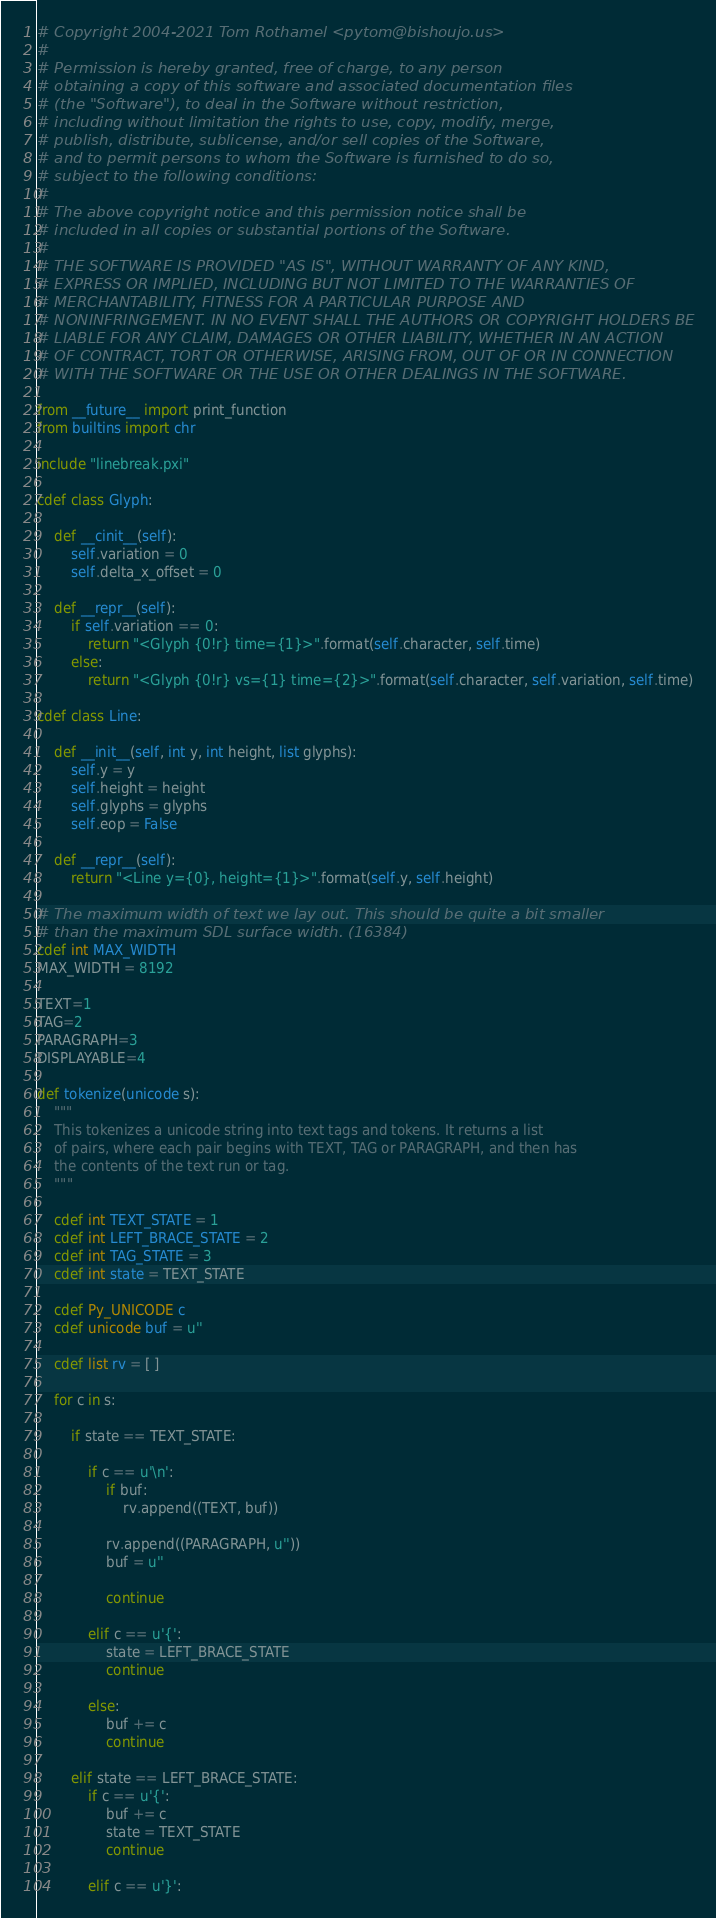Convert code to text. <code><loc_0><loc_0><loc_500><loc_500><_Cython_># Copyright 2004-2021 Tom Rothamel <pytom@bishoujo.us>
#
# Permission is hereby granted, free of charge, to any person
# obtaining a copy of this software and associated documentation files
# (the "Software"), to deal in the Software without restriction,
# including without limitation the rights to use, copy, modify, merge,
# publish, distribute, sublicense, and/or sell copies of the Software,
# and to permit persons to whom the Software is furnished to do so,
# subject to the following conditions:
#
# The above copyright notice and this permission notice shall be
# included in all copies or substantial portions of the Software.
#
# THE SOFTWARE IS PROVIDED "AS IS", WITHOUT WARRANTY OF ANY KIND,
# EXPRESS OR IMPLIED, INCLUDING BUT NOT LIMITED TO THE WARRANTIES OF
# MERCHANTABILITY, FITNESS FOR A PARTICULAR PURPOSE AND
# NONINFRINGEMENT. IN NO EVENT SHALL THE AUTHORS OR COPYRIGHT HOLDERS BE
# LIABLE FOR ANY CLAIM, DAMAGES OR OTHER LIABILITY, WHETHER IN AN ACTION
# OF CONTRACT, TORT OR OTHERWISE, ARISING FROM, OUT OF OR IN CONNECTION
# WITH THE SOFTWARE OR THE USE OR OTHER DEALINGS IN THE SOFTWARE.

from __future__ import print_function
from builtins import chr

include "linebreak.pxi"

cdef class Glyph:

    def __cinit__(self):
        self.variation = 0
        self.delta_x_offset = 0

    def __repr__(self):
        if self.variation == 0:
            return "<Glyph {0!r} time={1}>".format(self.character, self.time)
        else:
            return "<Glyph {0!r} vs={1} time={2}>".format(self.character, self.variation, self.time)

cdef class Line:

    def __init__(self, int y, int height, list glyphs):
        self.y = y
        self.height = height
        self.glyphs = glyphs
        self.eop = False

    def __repr__(self):
        return "<Line y={0}, height={1}>".format(self.y, self.height)

# The maximum width of text we lay out. This should be quite a bit smaller
# than the maximum SDL surface width. (16384)
cdef int MAX_WIDTH
MAX_WIDTH = 8192

TEXT=1
TAG=2
PARAGRAPH=3
DISPLAYABLE=4

def tokenize(unicode s):
    """
    This tokenizes a unicode string into text tags and tokens. It returns a list
    of pairs, where each pair begins with TEXT, TAG or PARAGRAPH, and then has
    the contents of the text run or tag.
    """

    cdef int TEXT_STATE = 1
    cdef int LEFT_BRACE_STATE = 2
    cdef int TAG_STATE = 3
    cdef int state = TEXT_STATE

    cdef Py_UNICODE c
    cdef unicode buf = u''

    cdef list rv = [ ]

    for c in s:

        if state == TEXT_STATE:

            if c == u'\n':
                if buf:
                    rv.append((TEXT, buf))

                rv.append((PARAGRAPH, u''))
                buf = u''

                continue

            elif c == u'{':
                state = LEFT_BRACE_STATE
                continue

            else:
                buf += c
                continue

        elif state == LEFT_BRACE_STATE:
            if c == u'{':
                buf += c
                state = TEXT_STATE
                continue

            elif c == u'}':</code> 